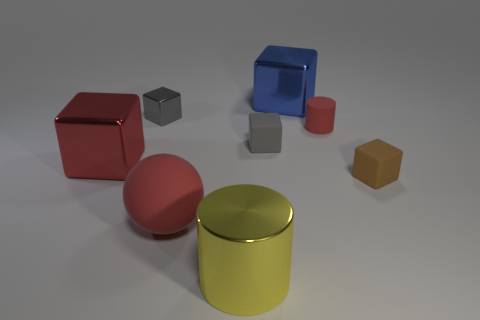How many other objects are there of the same size as the blue thing?
Your answer should be very brief. 3. There is a big rubber object; is its color the same as the tiny rubber object to the left of the large blue metal thing?
Your answer should be compact. No. What number of things are tiny cyan metallic blocks or yellow metal cylinders?
Your response must be concise. 1. Are there any other things of the same color as the tiny cylinder?
Your response must be concise. Yes. Does the large red block have the same material as the red object that is in front of the brown matte thing?
Your response must be concise. No. There is a large red object in front of the red object that is left of the big matte ball; what is its shape?
Provide a succinct answer. Sphere. There is a red object that is behind the sphere and to the right of the gray metal object; what is its shape?
Ensure brevity in your answer.  Cylinder. What number of objects are red rubber things or tiny rubber objects in front of the red metal object?
Provide a short and direct response. 3. What material is the red object that is the same shape as the blue object?
Ensure brevity in your answer.  Metal. Are there any other things that have the same material as the large yellow object?
Your response must be concise. Yes. 